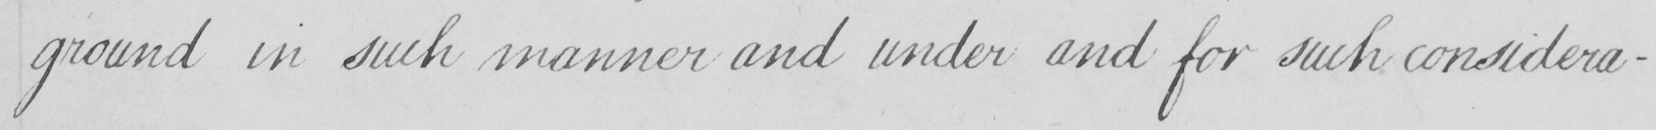Please provide the text content of this handwritten line. ground in such manner and under and for such considera- 